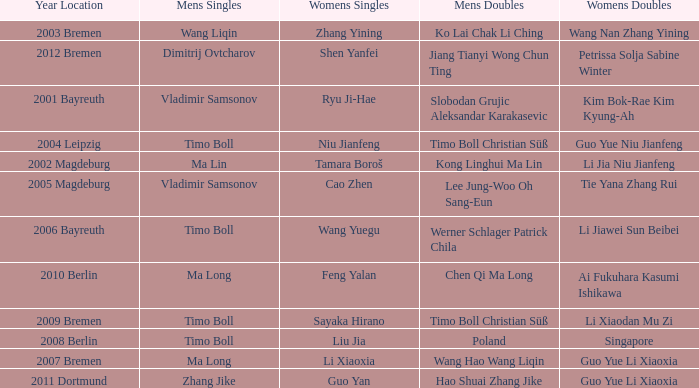Who won Womens Singles in the year that Ma Lin won Mens Singles? Tamara Boroš. 